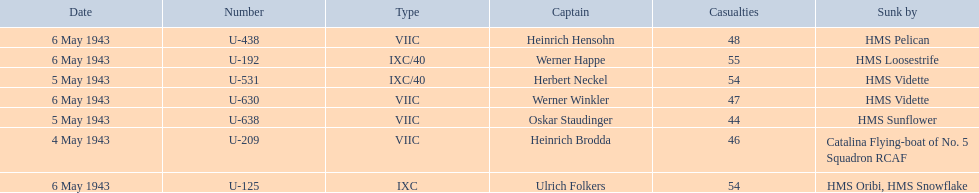Which sunken u-boat had the most casualties U-192. Can you parse all the data within this table? {'header': ['Date', 'Number', 'Type', 'Captain', 'Casualties', 'Sunk by'], 'rows': [['6 May 1943', 'U-438', 'VIIC', 'Heinrich Hensohn', '48', 'HMS Pelican'], ['6 May 1943', 'U-192', 'IXC/40', 'Werner Happe', '55', 'HMS Loosestrife'], ['5 May 1943', 'U-531', 'IXC/40', 'Herbert Neckel', '54', 'HMS Vidette'], ['6 May 1943', 'U-630', 'VIIC', 'Werner Winkler', '47', 'HMS Vidette'], ['5 May 1943', 'U-638', 'VIIC', 'Oskar Staudinger', '44', 'HMS Sunflower'], ['4 May 1943', 'U-209', 'VIIC', 'Heinrich Brodda', '46', 'Catalina Flying-boat of No. 5 Squadron RCAF'], ['6 May 1943', 'U-125', 'IXC', 'Ulrich Folkers', '54', 'HMS Oribi, HMS Snowflake']]} 